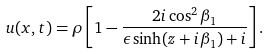Convert formula to latex. <formula><loc_0><loc_0><loc_500><loc_500>u ( x , t ) = \rho \left [ 1 - \frac { 2 i \cos ^ { 2 } \beta _ { 1 } } { \epsilon \sinh ( z + i \beta _ { 1 } ) + i } \right ] .</formula> 